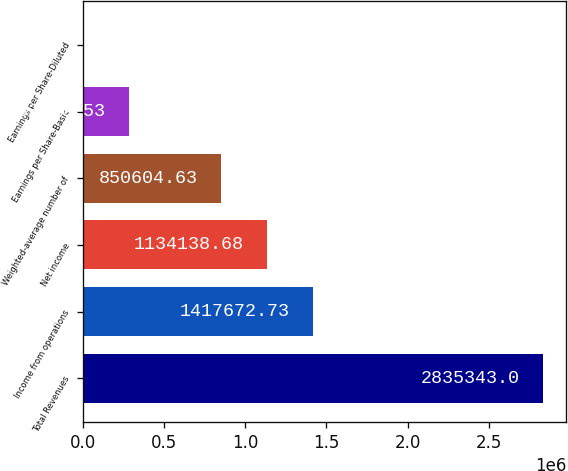Convert chart. <chart><loc_0><loc_0><loc_500><loc_500><bar_chart><fcel>Total Revenues<fcel>Income from operations<fcel>Net income<fcel>Weighted-average number of<fcel>Earnings per Share-Basic<fcel>Earnings per Share-Diluted<nl><fcel>2.83534e+06<fcel>1.41767e+06<fcel>1.13414e+06<fcel>850605<fcel>283537<fcel>2.48<nl></chart> 